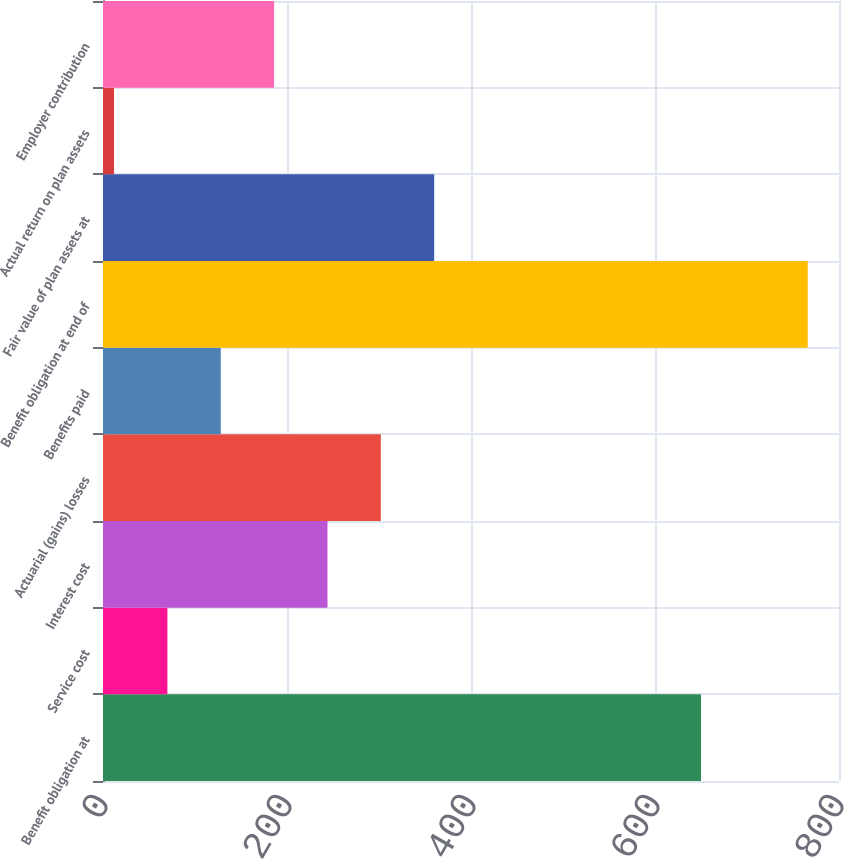<chart> <loc_0><loc_0><loc_500><loc_500><bar_chart><fcel>Benefit obligation at<fcel>Service cost<fcel>Interest cost<fcel>Actuarial (gains) losses<fcel>Benefits paid<fcel>Benefit obligation at end of<fcel>Fair value of plan assets at<fcel>Actual return on plan assets<fcel>Employer contribution<nl><fcel>650<fcel>70<fcel>244<fcel>302<fcel>128<fcel>766<fcel>360<fcel>12<fcel>186<nl></chart> 